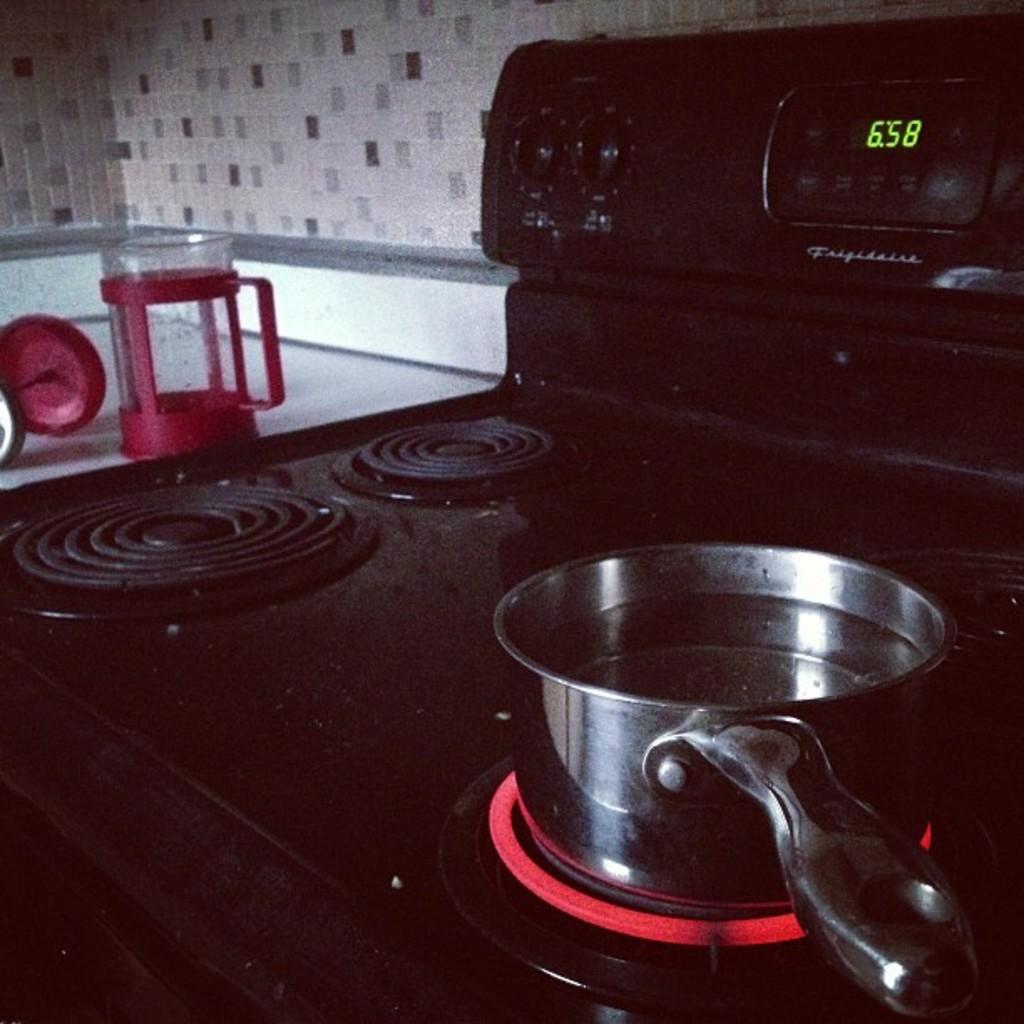What time is it according to the stove's clock?
Keep it short and to the point. 6:58. What time is it?
Your response must be concise. 6:58. 